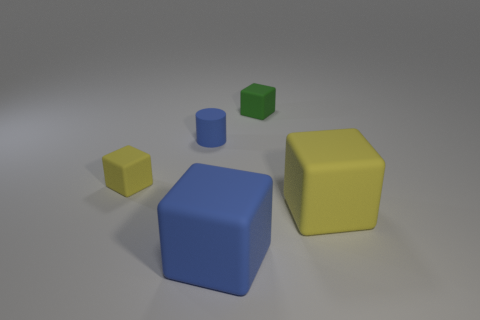Subtract all tiny yellow cubes. How many cubes are left? 3 Add 5 blue blocks. How many objects exist? 10 Subtract all green cubes. How many cubes are left? 3 Subtract 0 purple blocks. How many objects are left? 5 Subtract all cylinders. How many objects are left? 4 Subtract 1 blocks. How many blocks are left? 3 Subtract all green cubes. Subtract all green spheres. How many cubes are left? 3 Subtract all yellow balls. How many green cubes are left? 1 Subtract all tiny green rubber blocks. Subtract all big yellow rubber objects. How many objects are left? 3 Add 1 cylinders. How many cylinders are left? 2 